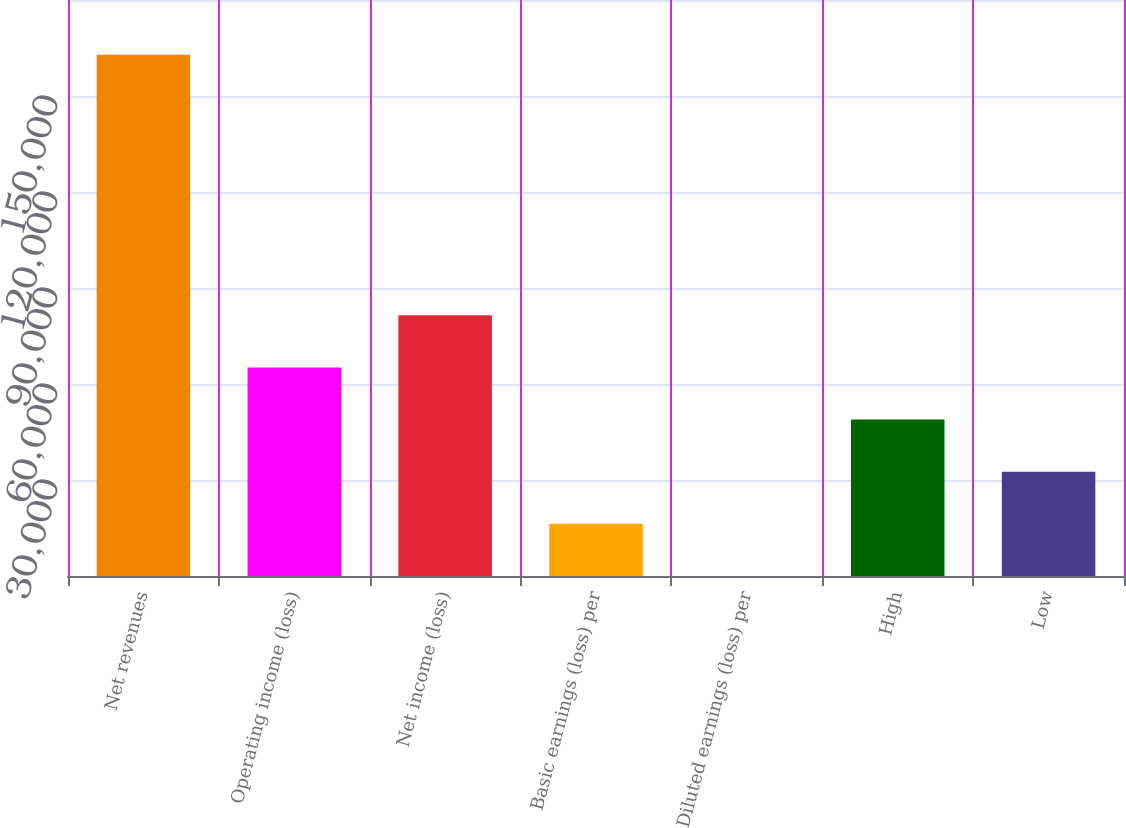Convert chart. <chart><loc_0><loc_0><loc_500><loc_500><bar_chart><fcel>Net revenues<fcel>Operating income (loss)<fcel>Net income (loss)<fcel>Basic earnings (loss) per<fcel>Diluted earnings (loss) per<fcel>High<fcel>Low<nl><fcel>162897<fcel>65158.8<fcel>81448.5<fcel>16289.7<fcel>0.04<fcel>48869.1<fcel>32579.4<nl></chart> 